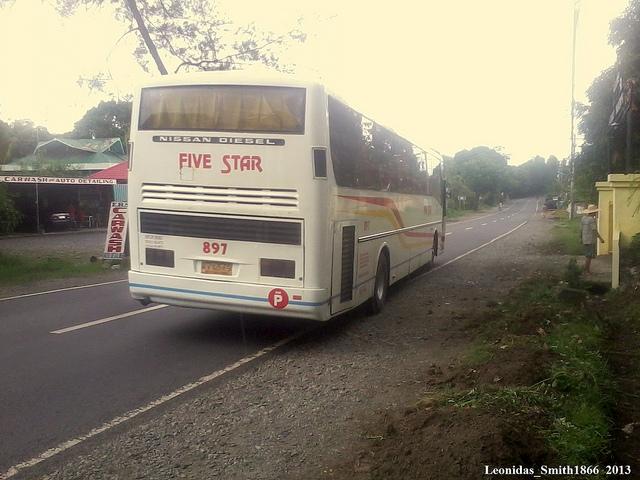What number is above the license plate?
Answer briefly. 897. What color are the letters on the bus?
Answer briefly. Red. What number is in front of STAR?
Be succinct. 5. 